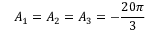<formula> <loc_0><loc_0><loc_500><loc_500>A _ { 1 } = A _ { 2 } = A _ { 3 } = - \frac { 2 0 \pi } { 3 }</formula> 